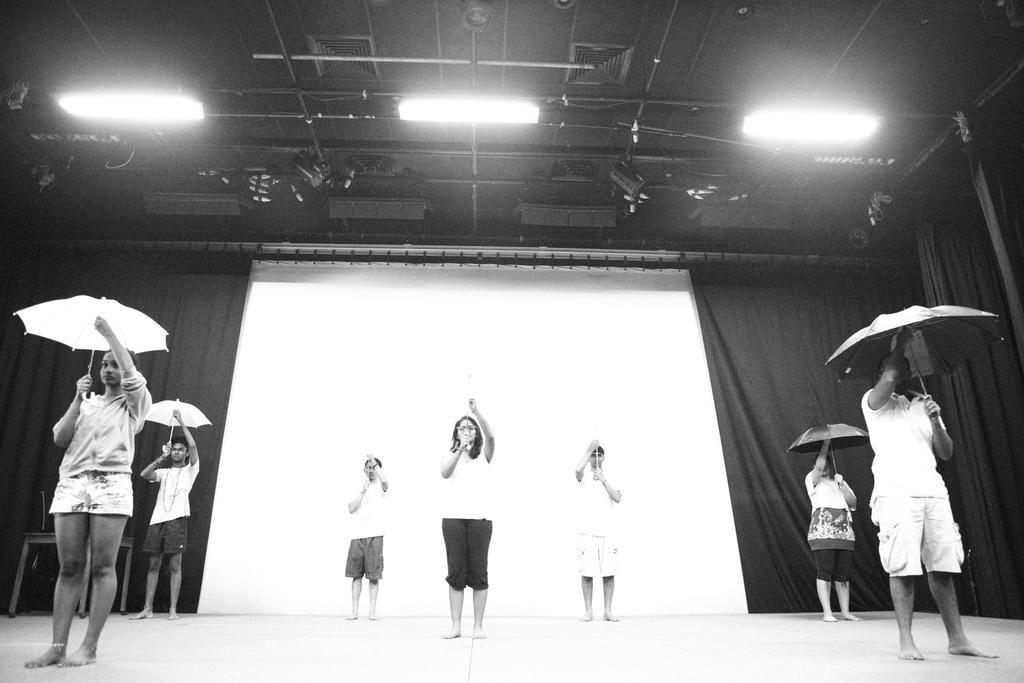How would you summarize this image in a sentence or two? This is a black and white picture. In this picture, we see the people are standing and they are holding the umbrellas in their hands. Behind them, we see a board in white color. Beside that, we see a sheet. At the top, we see the lights and the ceiling of the room. This picture might be clicked in the program. 